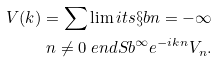Convert formula to latex. <formula><loc_0><loc_0><loc_500><loc_500>V ( k ) = \sum \lim i t s \S b n = - \infty \\ n \neq 0 \ e n d S b ^ { \infty } e ^ { - i k n } V _ { n } .</formula> 